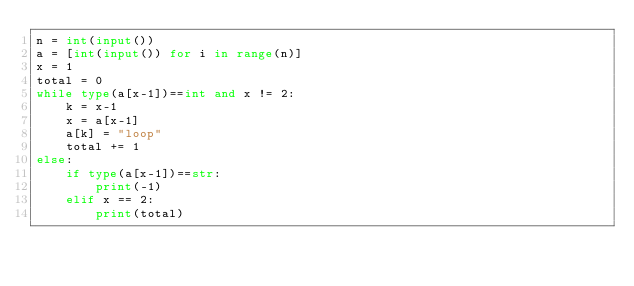Convert code to text. <code><loc_0><loc_0><loc_500><loc_500><_Python_>n = int(input())
a = [int(input()) for i in range(n)]
x = 1
total = 0
while type(a[x-1])==int and x != 2:
    k = x-1
    x = a[x-1]
    a[k] = "loop"
    total += 1
else:
    if type(a[x-1])==str:
        print(-1)
    elif x == 2:
        print(total)
</code> 